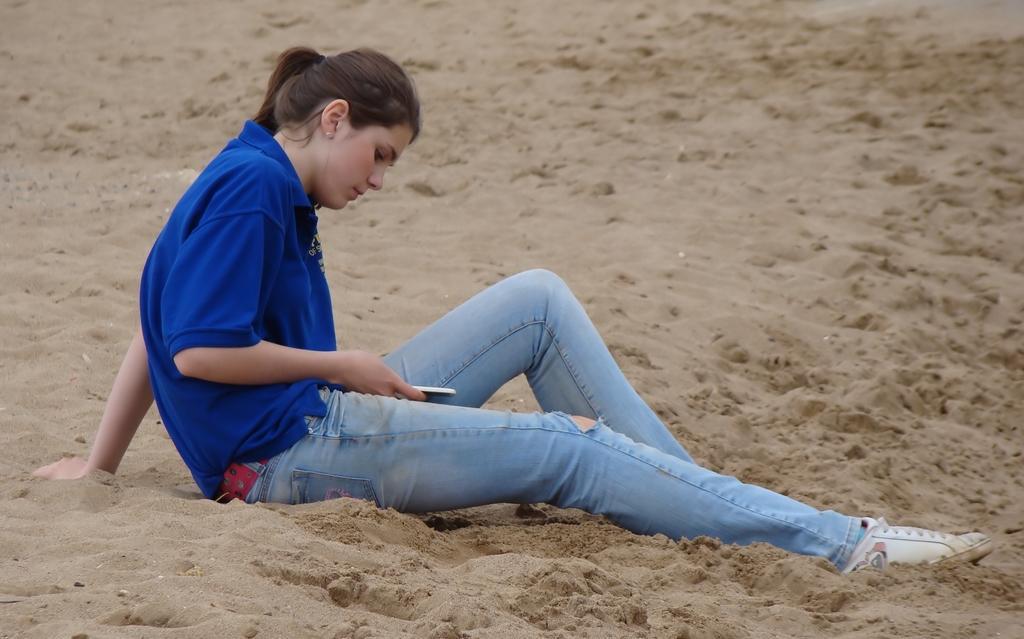In one or two sentences, can you explain what this image depicts? There is a woman sitting on the sand and operating a mobile phone, she is wearing jeans and blue shirt. 